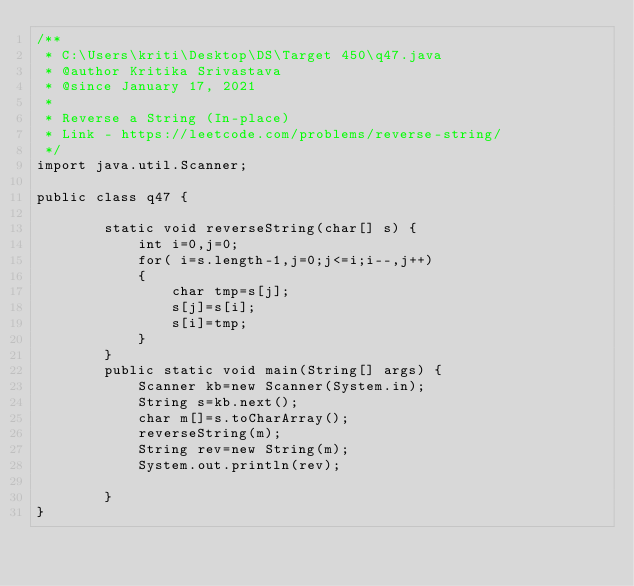Convert code to text. <code><loc_0><loc_0><loc_500><loc_500><_Java_>/**
 * C:\Users\kriti\Desktop\DS\Target 450\q47.java
 * @author Kritika Srivastava
 * @since January 17, 2021
 *
 * Reverse a String (In-place)
 * Link - https://leetcode.com/problems/reverse-string/
 */
import java.util.Scanner;

public class q47 {
    
        static void reverseString(char[] s) {
            int i=0,j=0;
            for( i=s.length-1,j=0;j<=i;i--,j++)
            {
                char tmp=s[j];
                s[j]=s[i];
                s[i]=tmp;
            }   
        }
        public static void main(String[] args) {
            Scanner kb=new Scanner(System.in);
            String s=kb.next();
            char m[]=s.toCharArray();
            reverseString(m);
            String rev=new String(m);
            System.out.println(rev);

        }
}
</code> 